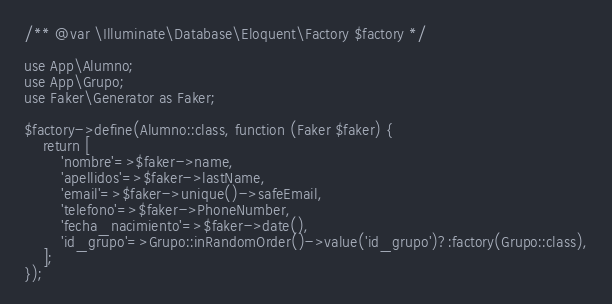Convert code to text. <code><loc_0><loc_0><loc_500><loc_500><_PHP_>
/** @var \Illuminate\Database\Eloquent\Factory $factory */

use App\Alumno;
use App\Grupo;
use Faker\Generator as Faker;

$factory->define(Alumno::class, function (Faker $faker) {
    return [
        'nombre'=>$faker->name,
        'apellidos'=>$faker->lastName,
        'email'=>$faker->unique()->safeEmail,
        'telefono'=>$faker->PhoneNumber,
        'fecha_nacimiento'=>$faker->date(),
        'id_grupo'=>Grupo::inRandomOrder()->value('id_grupo')?:factory(Grupo::class),
    ];
});
</code> 